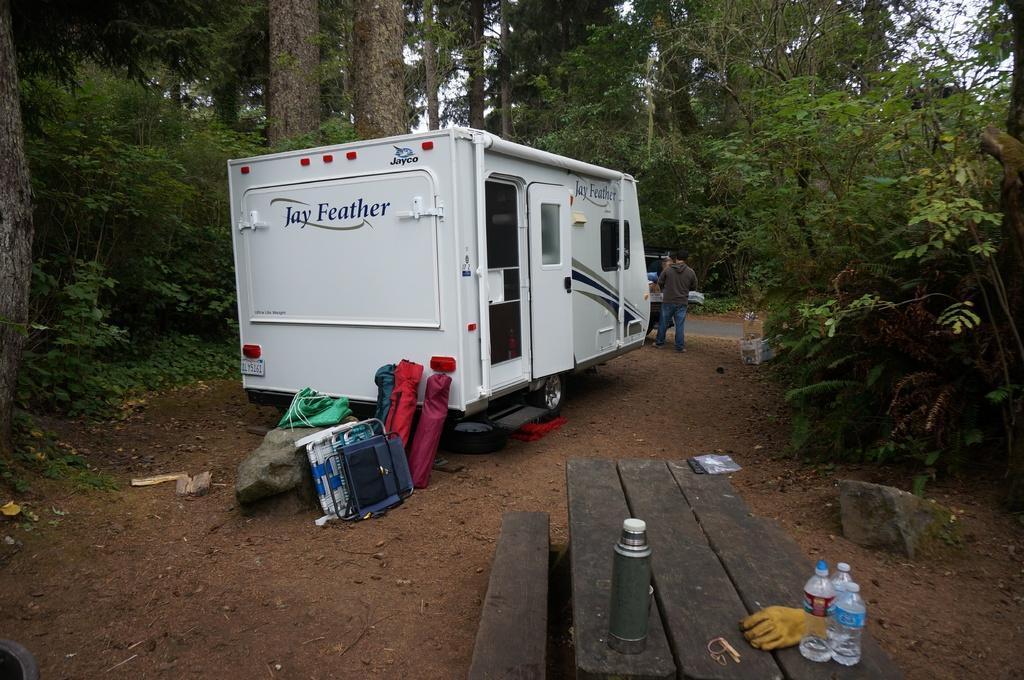How would you summarize this image in a sentence or two? The image is outside of the city. In the image we can see a white color van, on van we can see a chair,stone and green color cloth. On right side of the image there is a man standing near a van gate and we can also see a table on right side. On table there are bottles,gloves. In background there are trees and sky is on top. 